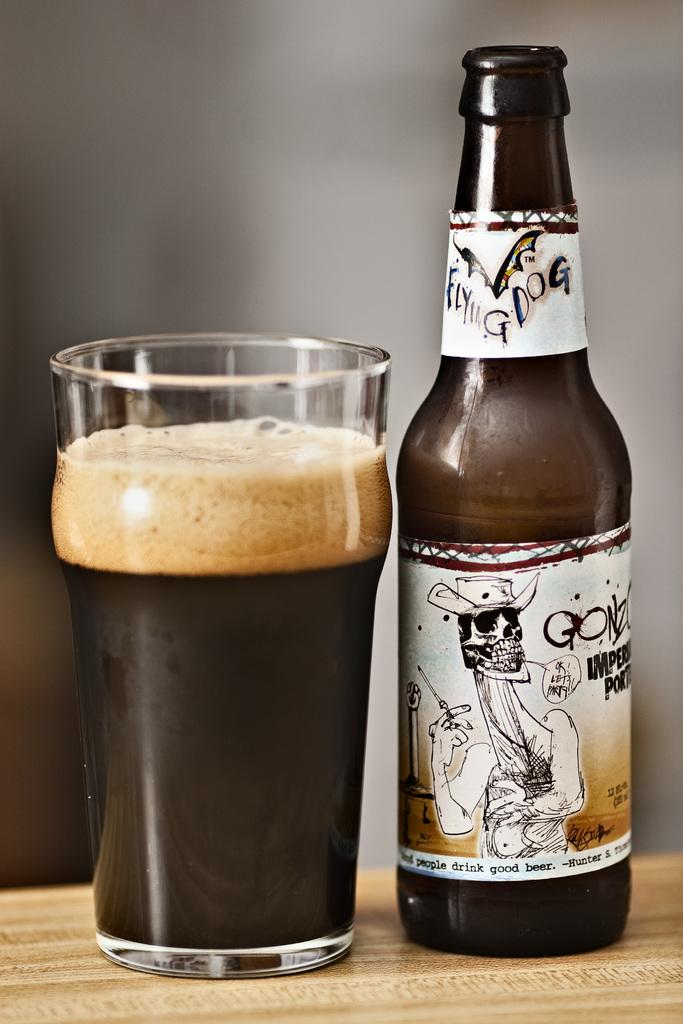<image>
Share a concise interpretation of the image provided. A bottle of Flying Dog beer sits on a table next to full glass. 